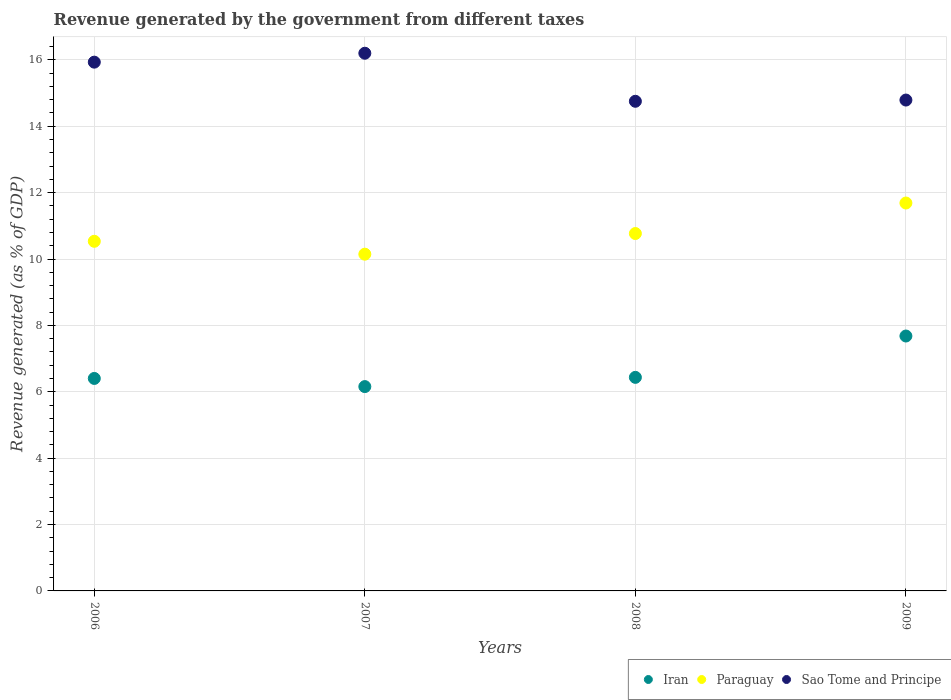What is the revenue generated by the government in Iran in 2006?
Offer a very short reply. 6.4. Across all years, what is the maximum revenue generated by the government in Iran?
Provide a short and direct response. 7.68. Across all years, what is the minimum revenue generated by the government in Paraguay?
Your answer should be compact. 10.15. In which year was the revenue generated by the government in Paraguay maximum?
Your response must be concise. 2009. In which year was the revenue generated by the government in Iran minimum?
Provide a short and direct response. 2007. What is the total revenue generated by the government in Iran in the graph?
Ensure brevity in your answer.  26.67. What is the difference between the revenue generated by the government in Iran in 2006 and that in 2008?
Make the answer very short. -0.03. What is the difference between the revenue generated by the government in Paraguay in 2009 and the revenue generated by the government in Iran in 2007?
Give a very brief answer. 5.53. What is the average revenue generated by the government in Paraguay per year?
Your answer should be compact. 10.78. In the year 2009, what is the difference between the revenue generated by the government in Paraguay and revenue generated by the government in Iran?
Offer a terse response. 4.01. In how many years, is the revenue generated by the government in Iran greater than 6.4 %?
Offer a very short reply. 3. What is the ratio of the revenue generated by the government in Sao Tome and Principe in 2006 to that in 2007?
Your response must be concise. 0.98. Is the difference between the revenue generated by the government in Paraguay in 2007 and 2008 greater than the difference between the revenue generated by the government in Iran in 2007 and 2008?
Give a very brief answer. No. What is the difference between the highest and the second highest revenue generated by the government in Sao Tome and Principe?
Your response must be concise. 0.27. What is the difference between the highest and the lowest revenue generated by the government in Sao Tome and Principe?
Make the answer very short. 1.45. Is the revenue generated by the government in Sao Tome and Principe strictly greater than the revenue generated by the government in Paraguay over the years?
Provide a succinct answer. Yes. Is the revenue generated by the government in Iran strictly less than the revenue generated by the government in Sao Tome and Principe over the years?
Your answer should be very brief. Yes. Are the values on the major ticks of Y-axis written in scientific E-notation?
Provide a short and direct response. No. Does the graph contain any zero values?
Ensure brevity in your answer.  No. How many legend labels are there?
Provide a short and direct response. 3. How are the legend labels stacked?
Provide a succinct answer. Horizontal. What is the title of the graph?
Provide a short and direct response. Revenue generated by the government from different taxes. Does "Macedonia" appear as one of the legend labels in the graph?
Provide a succinct answer. No. What is the label or title of the X-axis?
Keep it short and to the point. Years. What is the label or title of the Y-axis?
Give a very brief answer. Revenue generated (as % of GDP). What is the Revenue generated (as % of GDP) in Iran in 2006?
Keep it short and to the point. 6.4. What is the Revenue generated (as % of GDP) in Paraguay in 2006?
Your answer should be compact. 10.53. What is the Revenue generated (as % of GDP) of Sao Tome and Principe in 2006?
Make the answer very short. 15.93. What is the Revenue generated (as % of GDP) of Iran in 2007?
Your answer should be compact. 6.16. What is the Revenue generated (as % of GDP) of Paraguay in 2007?
Provide a succinct answer. 10.15. What is the Revenue generated (as % of GDP) of Sao Tome and Principe in 2007?
Provide a succinct answer. 16.2. What is the Revenue generated (as % of GDP) of Iran in 2008?
Your answer should be very brief. 6.43. What is the Revenue generated (as % of GDP) of Paraguay in 2008?
Your answer should be very brief. 10.77. What is the Revenue generated (as % of GDP) in Sao Tome and Principe in 2008?
Ensure brevity in your answer.  14.75. What is the Revenue generated (as % of GDP) in Iran in 2009?
Ensure brevity in your answer.  7.68. What is the Revenue generated (as % of GDP) of Paraguay in 2009?
Your answer should be compact. 11.69. What is the Revenue generated (as % of GDP) of Sao Tome and Principe in 2009?
Your response must be concise. 14.79. Across all years, what is the maximum Revenue generated (as % of GDP) of Iran?
Give a very brief answer. 7.68. Across all years, what is the maximum Revenue generated (as % of GDP) in Paraguay?
Keep it short and to the point. 11.69. Across all years, what is the maximum Revenue generated (as % of GDP) of Sao Tome and Principe?
Make the answer very short. 16.2. Across all years, what is the minimum Revenue generated (as % of GDP) of Iran?
Keep it short and to the point. 6.16. Across all years, what is the minimum Revenue generated (as % of GDP) in Paraguay?
Offer a very short reply. 10.15. Across all years, what is the minimum Revenue generated (as % of GDP) in Sao Tome and Principe?
Provide a short and direct response. 14.75. What is the total Revenue generated (as % of GDP) of Iran in the graph?
Your answer should be very brief. 26.67. What is the total Revenue generated (as % of GDP) in Paraguay in the graph?
Keep it short and to the point. 43.13. What is the total Revenue generated (as % of GDP) in Sao Tome and Principe in the graph?
Your answer should be compact. 61.67. What is the difference between the Revenue generated (as % of GDP) of Iran in 2006 and that in 2007?
Your answer should be compact. 0.25. What is the difference between the Revenue generated (as % of GDP) in Paraguay in 2006 and that in 2007?
Offer a terse response. 0.39. What is the difference between the Revenue generated (as % of GDP) in Sao Tome and Principe in 2006 and that in 2007?
Make the answer very short. -0.27. What is the difference between the Revenue generated (as % of GDP) in Iran in 2006 and that in 2008?
Keep it short and to the point. -0.03. What is the difference between the Revenue generated (as % of GDP) of Paraguay in 2006 and that in 2008?
Provide a succinct answer. -0.23. What is the difference between the Revenue generated (as % of GDP) in Sao Tome and Principe in 2006 and that in 2008?
Give a very brief answer. 1.18. What is the difference between the Revenue generated (as % of GDP) in Iran in 2006 and that in 2009?
Ensure brevity in your answer.  -1.28. What is the difference between the Revenue generated (as % of GDP) in Paraguay in 2006 and that in 2009?
Give a very brief answer. -1.15. What is the difference between the Revenue generated (as % of GDP) of Sao Tome and Principe in 2006 and that in 2009?
Provide a short and direct response. 1.14. What is the difference between the Revenue generated (as % of GDP) in Iran in 2007 and that in 2008?
Give a very brief answer. -0.28. What is the difference between the Revenue generated (as % of GDP) of Paraguay in 2007 and that in 2008?
Your response must be concise. -0.62. What is the difference between the Revenue generated (as % of GDP) in Sao Tome and Principe in 2007 and that in 2008?
Provide a succinct answer. 1.45. What is the difference between the Revenue generated (as % of GDP) of Iran in 2007 and that in 2009?
Your answer should be very brief. -1.52. What is the difference between the Revenue generated (as % of GDP) in Paraguay in 2007 and that in 2009?
Offer a terse response. -1.54. What is the difference between the Revenue generated (as % of GDP) in Sao Tome and Principe in 2007 and that in 2009?
Your response must be concise. 1.41. What is the difference between the Revenue generated (as % of GDP) of Iran in 2008 and that in 2009?
Offer a very short reply. -1.25. What is the difference between the Revenue generated (as % of GDP) in Paraguay in 2008 and that in 2009?
Your answer should be compact. -0.92. What is the difference between the Revenue generated (as % of GDP) of Sao Tome and Principe in 2008 and that in 2009?
Keep it short and to the point. -0.04. What is the difference between the Revenue generated (as % of GDP) of Iran in 2006 and the Revenue generated (as % of GDP) of Paraguay in 2007?
Make the answer very short. -3.74. What is the difference between the Revenue generated (as % of GDP) of Iran in 2006 and the Revenue generated (as % of GDP) of Sao Tome and Principe in 2007?
Make the answer very short. -9.8. What is the difference between the Revenue generated (as % of GDP) of Paraguay in 2006 and the Revenue generated (as % of GDP) of Sao Tome and Principe in 2007?
Offer a very short reply. -5.67. What is the difference between the Revenue generated (as % of GDP) of Iran in 2006 and the Revenue generated (as % of GDP) of Paraguay in 2008?
Make the answer very short. -4.37. What is the difference between the Revenue generated (as % of GDP) of Iran in 2006 and the Revenue generated (as % of GDP) of Sao Tome and Principe in 2008?
Give a very brief answer. -8.35. What is the difference between the Revenue generated (as % of GDP) in Paraguay in 2006 and the Revenue generated (as % of GDP) in Sao Tome and Principe in 2008?
Keep it short and to the point. -4.22. What is the difference between the Revenue generated (as % of GDP) in Iran in 2006 and the Revenue generated (as % of GDP) in Paraguay in 2009?
Offer a terse response. -5.29. What is the difference between the Revenue generated (as % of GDP) of Iran in 2006 and the Revenue generated (as % of GDP) of Sao Tome and Principe in 2009?
Offer a terse response. -8.39. What is the difference between the Revenue generated (as % of GDP) in Paraguay in 2006 and the Revenue generated (as % of GDP) in Sao Tome and Principe in 2009?
Your answer should be compact. -4.26. What is the difference between the Revenue generated (as % of GDP) of Iran in 2007 and the Revenue generated (as % of GDP) of Paraguay in 2008?
Offer a terse response. -4.61. What is the difference between the Revenue generated (as % of GDP) in Iran in 2007 and the Revenue generated (as % of GDP) in Sao Tome and Principe in 2008?
Make the answer very short. -8.6. What is the difference between the Revenue generated (as % of GDP) of Paraguay in 2007 and the Revenue generated (as % of GDP) of Sao Tome and Principe in 2008?
Offer a very short reply. -4.61. What is the difference between the Revenue generated (as % of GDP) in Iran in 2007 and the Revenue generated (as % of GDP) in Paraguay in 2009?
Offer a terse response. -5.53. What is the difference between the Revenue generated (as % of GDP) of Iran in 2007 and the Revenue generated (as % of GDP) of Sao Tome and Principe in 2009?
Your answer should be compact. -8.63. What is the difference between the Revenue generated (as % of GDP) in Paraguay in 2007 and the Revenue generated (as % of GDP) in Sao Tome and Principe in 2009?
Your answer should be very brief. -4.64. What is the difference between the Revenue generated (as % of GDP) of Iran in 2008 and the Revenue generated (as % of GDP) of Paraguay in 2009?
Your response must be concise. -5.25. What is the difference between the Revenue generated (as % of GDP) of Iran in 2008 and the Revenue generated (as % of GDP) of Sao Tome and Principe in 2009?
Ensure brevity in your answer.  -8.35. What is the difference between the Revenue generated (as % of GDP) in Paraguay in 2008 and the Revenue generated (as % of GDP) in Sao Tome and Principe in 2009?
Offer a terse response. -4.02. What is the average Revenue generated (as % of GDP) in Iran per year?
Provide a succinct answer. 6.67. What is the average Revenue generated (as % of GDP) of Paraguay per year?
Offer a terse response. 10.78. What is the average Revenue generated (as % of GDP) of Sao Tome and Principe per year?
Your response must be concise. 15.42. In the year 2006, what is the difference between the Revenue generated (as % of GDP) in Iran and Revenue generated (as % of GDP) in Paraguay?
Your answer should be compact. -4.13. In the year 2006, what is the difference between the Revenue generated (as % of GDP) in Iran and Revenue generated (as % of GDP) in Sao Tome and Principe?
Give a very brief answer. -9.53. In the year 2006, what is the difference between the Revenue generated (as % of GDP) of Paraguay and Revenue generated (as % of GDP) of Sao Tome and Principe?
Keep it short and to the point. -5.4. In the year 2007, what is the difference between the Revenue generated (as % of GDP) in Iran and Revenue generated (as % of GDP) in Paraguay?
Your response must be concise. -3.99. In the year 2007, what is the difference between the Revenue generated (as % of GDP) of Iran and Revenue generated (as % of GDP) of Sao Tome and Principe?
Your response must be concise. -10.04. In the year 2007, what is the difference between the Revenue generated (as % of GDP) in Paraguay and Revenue generated (as % of GDP) in Sao Tome and Principe?
Your answer should be very brief. -6.05. In the year 2008, what is the difference between the Revenue generated (as % of GDP) of Iran and Revenue generated (as % of GDP) of Paraguay?
Ensure brevity in your answer.  -4.33. In the year 2008, what is the difference between the Revenue generated (as % of GDP) of Iran and Revenue generated (as % of GDP) of Sao Tome and Principe?
Keep it short and to the point. -8.32. In the year 2008, what is the difference between the Revenue generated (as % of GDP) in Paraguay and Revenue generated (as % of GDP) in Sao Tome and Principe?
Provide a short and direct response. -3.98. In the year 2009, what is the difference between the Revenue generated (as % of GDP) of Iran and Revenue generated (as % of GDP) of Paraguay?
Your response must be concise. -4.01. In the year 2009, what is the difference between the Revenue generated (as % of GDP) of Iran and Revenue generated (as % of GDP) of Sao Tome and Principe?
Offer a terse response. -7.11. In the year 2009, what is the difference between the Revenue generated (as % of GDP) in Paraguay and Revenue generated (as % of GDP) in Sao Tome and Principe?
Ensure brevity in your answer.  -3.1. What is the ratio of the Revenue generated (as % of GDP) in Iran in 2006 to that in 2007?
Make the answer very short. 1.04. What is the ratio of the Revenue generated (as % of GDP) of Paraguay in 2006 to that in 2007?
Ensure brevity in your answer.  1.04. What is the ratio of the Revenue generated (as % of GDP) of Sao Tome and Principe in 2006 to that in 2007?
Give a very brief answer. 0.98. What is the ratio of the Revenue generated (as % of GDP) of Iran in 2006 to that in 2008?
Offer a terse response. 0.99. What is the ratio of the Revenue generated (as % of GDP) of Paraguay in 2006 to that in 2008?
Give a very brief answer. 0.98. What is the ratio of the Revenue generated (as % of GDP) of Sao Tome and Principe in 2006 to that in 2008?
Provide a succinct answer. 1.08. What is the ratio of the Revenue generated (as % of GDP) in Iran in 2006 to that in 2009?
Ensure brevity in your answer.  0.83. What is the ratio of the Revenue generated (as % of GDP) of Paraguay in 2006 to that in 2009?
Your answer should be compact. 0.9. What is the ratio of the Revenue generated (as % of GDP) in Sao Tome and Principe in 2006 to that in 2009?
Provide a succinct answer. 1.08. What is the ratio of the Revenue generated (as % of GDP) of Iran in 2007 to that in 2008?
Your answer should be compact. 0.96. What is the ratio of the Revenue generated (as % of GDP) of Paraguay in 2007 to that in 2008?
Your response must be concise. 0.94. What is the ratio of the Revenue generated (as % of GDP) in Sao Tome and Principe in 2007 to that in 2008?
Your response must be concise. 1.1. What is the ratio of the Revenue generated (as % of GDP) of Iran in 2007 to that in 2009?
Provide a short and direct response. 0.8. What is the ratio of the Revenue generated (as % of GDP) of Paraguay in 2007 to that in 2009?
Ensure brevity in your answer.  0.87. What is the ratio of the Revenue generated (as % of GDP) in Sao Tome and Principe in 2007 to that in 2009?
Provide a succinct answer. 1.1. What is the ratio of the Revenue generated (as % of GDP) of Iran in 2008 to that in 2009?
Offer a very short reply. 0.84. What is the ratio of the Revenue generated (as % of GDP) of Paraguay in 2008 to that in 2009?
Your response must be concise. 0.92. What is the difference between the highest and the second highest Revenue generated (as % of GDP) in Iran?
Ensure brevity in your answer.  1.25. What is the difference between the highest and the second highest Revenue generated (as % of GDP) in Paraguay?
Ensure brevity in your answer.  0.92. What is the difference between the highest and the second highest Revenue generated (as % of GDP) in Sao Tome and Principe?
Your response must be concise. 0.27. What is the difference between the highest and the lowest Revenue generated (as % of GDP) of Iran?
Ensure brevity in your answer.  1.52. What is the difference between the highest and the lowest Revenue generated (as % of GDP) of Paraguay?
Your answer should be compact. 1.54. What is the difference between the highest and the lowest Revenue generated (as % of GDP) in Sao Tome and Principe?
Your answer should be compact. 1.45. 